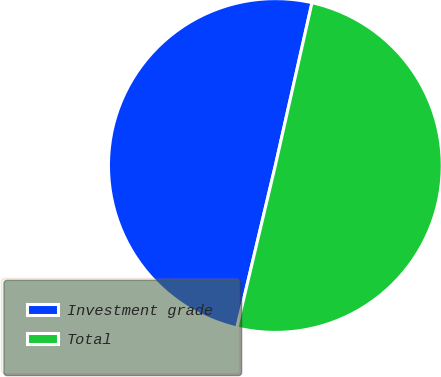Convert chart to OTSL. <chart><loc_0><loc_0><loc_500><loc_500><pie_chart><fcel>Investment grade<fcel>Total<nl><fcel>49.82%<fcel>50.18%<nl></chart> 